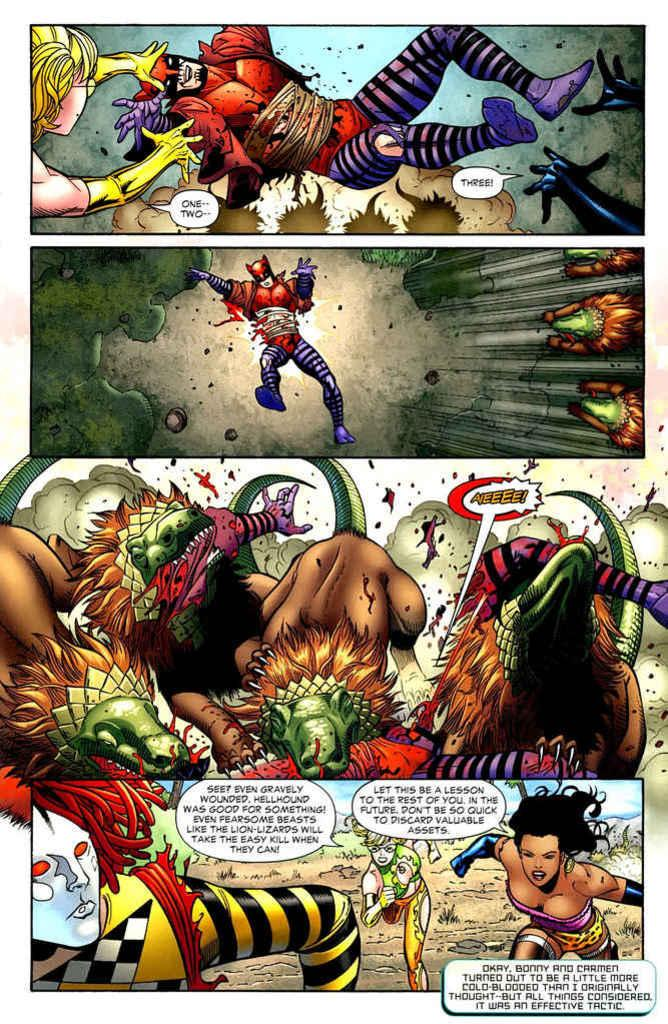What is the main subject in the center of the image? There is a poster in the center of the image. What type of characters are featured on the poster? The poster includes cartoon characters. Can you see a match being lit by a tiger in the image? There is no match or tiger present in the image; it only features a poster with cartoon characters. 